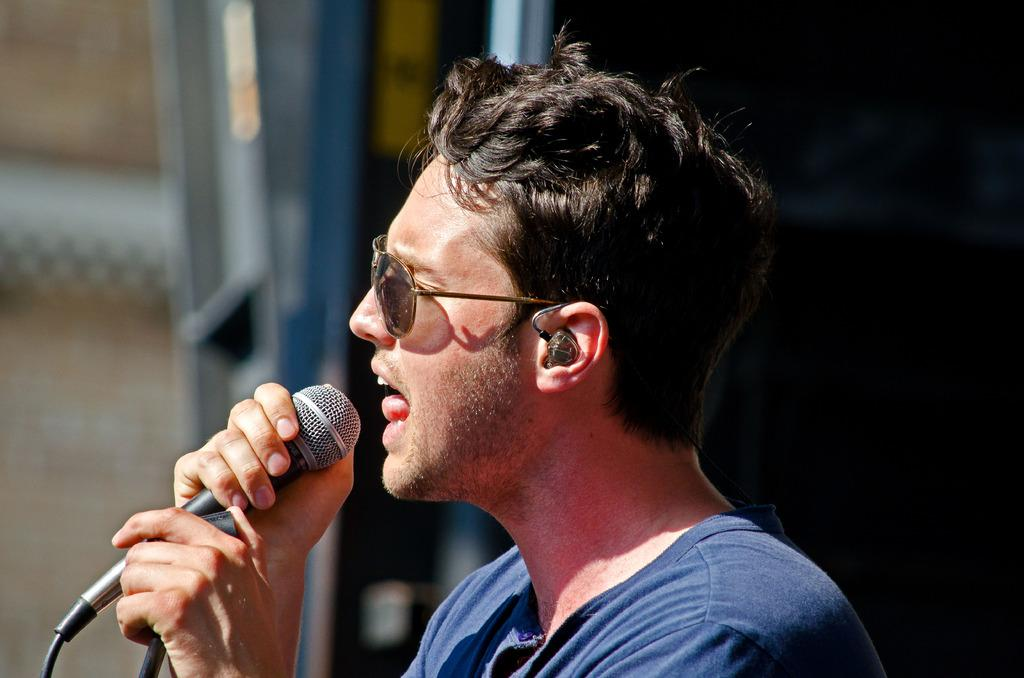What is the person in the image doing? The person is holding a microphone and talking. What is the person wearing on their face? The person is wearing a goggle. What color is the shirt the person is wearing? The person is wearing a blue shirt. What is the overall appearance of the image? The image is blurry and dark in color. What type of leaf can be seen falling in the image? There is no leaf present in the image; it features a person holding a microphone and talking. How does the feather contribute to the person's speech in the image? There is no feather present in the image, and therefore it does not contribute to the person's speech. 